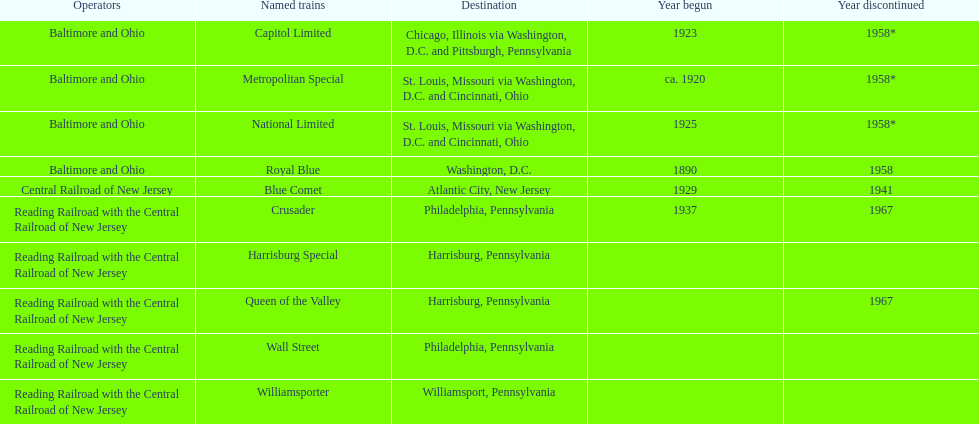Which other traine, other than wall street, had philadelphia as a destination? Crusader. 